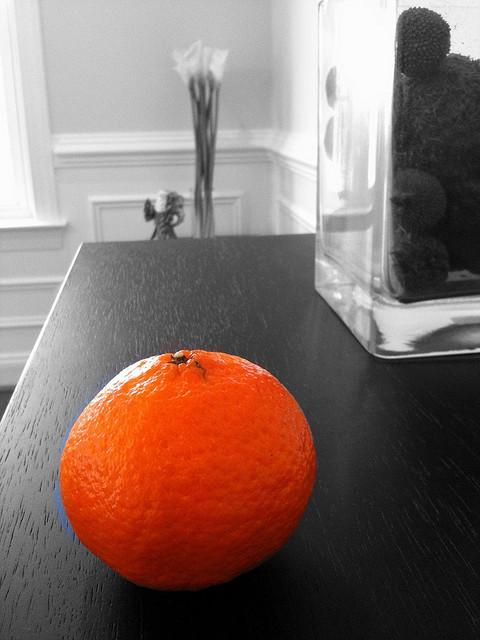Can this fruit be halved and juiced?
Keep it brief. Yes. Is this a regularly sized orange?
Be succinct. Yes. Is this photo in color?
Short answer required. Yes. Can you see a bottle with a cork?
Concise answer only. No. 